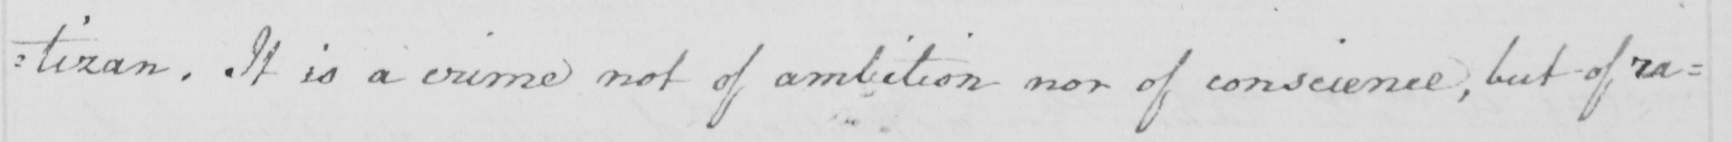Please transcribe the handwritten text in this image. tizan . It is a crime not of ambition nor of conscience , but of ra= 